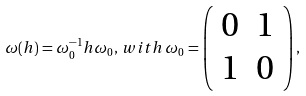Convert formula to latex. <formula><loc_0><loc_0><loc_500><loc_500>\omega ( h ) = \omega _ { 0 } ^ { - 1 } h \omega _ { 0 } , \, w i t h \, \omega _ { 0 } = \left ( \begin{array} { c c } { 0 } & { 1 } \\ { 1 } & { 0 } \end{array} \right ) ,</formula> 